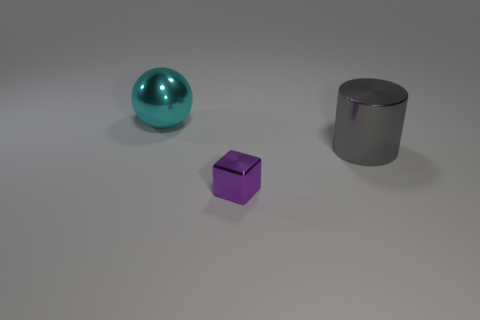What might be the relative sizes of these objects? The teal sphere appears to be the largest object, the gray cylinder is medium-sized, and the violet cube looks to be the smallest. Is there any indication of what materials these objects could be made from? While it's not possible to determine the exact materials from the image, the gray cylinder has a metallic sheen, suggesting it might be made of metal. The teal sphere and the violet cube have matte surfaces which could be made of plastic or painted metal. 